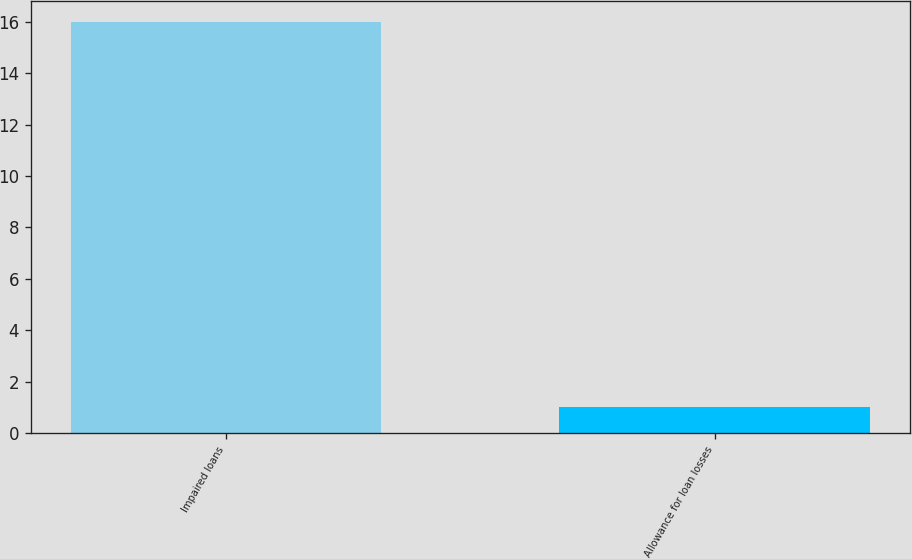Convert chart. <chart><loc_0><loc_0><loc_500><loc_500><bar_chart><fcel>Impaired loans<fcel>Allowance for loan losses<nl><fcel>16<fcel>1<nl></chart> 